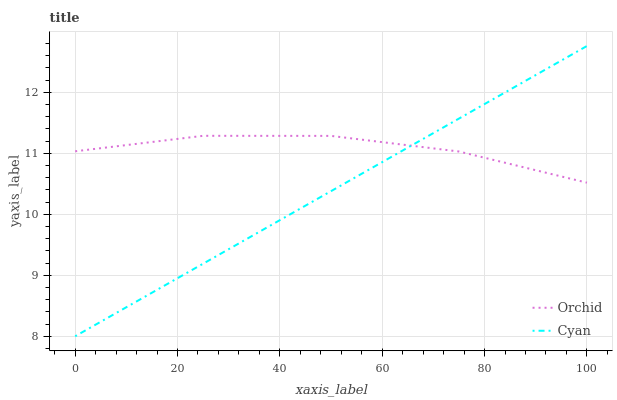Does Cyan have the minimum area under the curve?
Answer yes or no. Yes. Does Orchid have the maximum area under the curve?
Answer yes or no. Yes. Does Orchid have the minimum area under the curve?
Answer yes or no. No. Is Cyan the smoothest?
Answer yes or no. Yes. Is Orchid the roughest?
Answer yes or no. Yes. Is Orchid the smoothest?
Answer yes or no. No. Does Cyan have the lowest value?
Answer yes or no. Yes. Does Orchid have the lowest value?
Answer yes or no. No. Does Cyan have the highest value?
Answer yes or no. Yes. Does Orchid have the highest value?
Answer yes or no. No. Does Cyan intersect Orchid?
Answer yes or no. Yes. Is Cyan less than Orchid?
Answer yes or no. No. Is Cyan greater than Orchid?
Answer yes or no. No. 